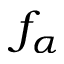Convert formula to latex. <formula><loc_0><loc_0><loc_500><loc_500>f _ { \alpha }</formula> 